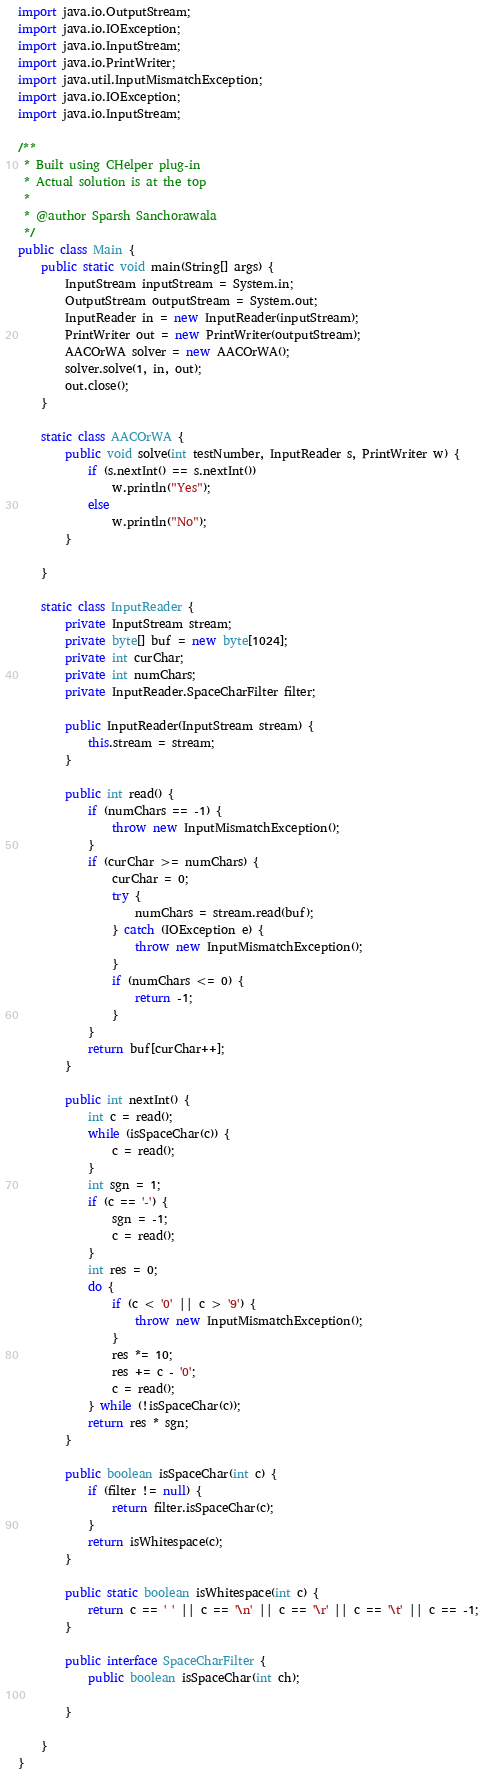Convert code to text. <code><loc_0><loc_0><loc_500><loc_500><_Java_>import java.io.OutputStream;
import java.io.IOException;
import java.io.InputStream;
import java.io.PrintWriter;
import java.util.InputMismatchException;
import java.io.IOException;
import java.io.InputStream;

/**
 * Built using CHelper plug-in
 * Actual solution is at the top
 *
 * @author Sparsh Sanchorawala
 */
public class Main {
    public static void main(String[] args) {
        InputStream inputStream = System.in;
        OutputStream outputStream = System.out;
        InputReader in = new InputReader(inputStream);
        PrintWriter out = new PrintWriter(outputStream);
        AACOrWA solver = new AACOrWA();
        solver.solve(1, in, out);
        out.close();
    }

    static class AACOrWA {
        public void solve(int testNumber, InputReader s, PrintWriter w) {
            if (s.nextInt() == s.nextInt())
                w.println("Yes");
            else
                w.println("No");
        }

    }

    static class InputReader {
        private InputStream stream;
        private byte[] buf = new byte[1024];
        private int curChar;
        private int numChars;
        private InputReader.SpaceCharFilter filter;

        public InputReader(InputStream stream) {
            this.stream = stream;
        }

        public int read() {
            if (numChars == -1) {
                throw new InputMismatchException();
            }
            if (curChar >= numChars) {
                curChar = 0;
                try {
                    numChars = stream.read(buf);
                } catch (IOException e) {
                    throw new InputMismatchException();
                }
                if (numChars <= 0) {
                    return -1;
                }
            }
            return buf[curChar++];
        }

        public int nextInt() {
            int c = read();
            while (isSpaceChar(c)) {
                c = read();
            }
            int sgn = 1;
            if (c == '-') {
                sgn = -1;
                c = read();
            }
            int res = 0;
            do {
                if (c < '0' || c > '9') {
                    throw new InputMismatchException();
                }
                res *= 10;
                res += c - '0';
                c = read();
            } while (!isSpaceChar(c));
            return res * sgn;
        }

        public boolean isSpaceChar(int c) {
            if (filter != null) {
                return filter.isSpaceChar(c);
            }
            return isWhitespace(c);
        }

        public static boolean isWhitespace(int c) {
            return c == ' ' || c == '\n' || c == '\r' || c == '\t' || c == -1;
        }

        public interface SpaceCharFilter {
            public boolean isSpaceChar(int ch);

        }

    }
}

</code> 